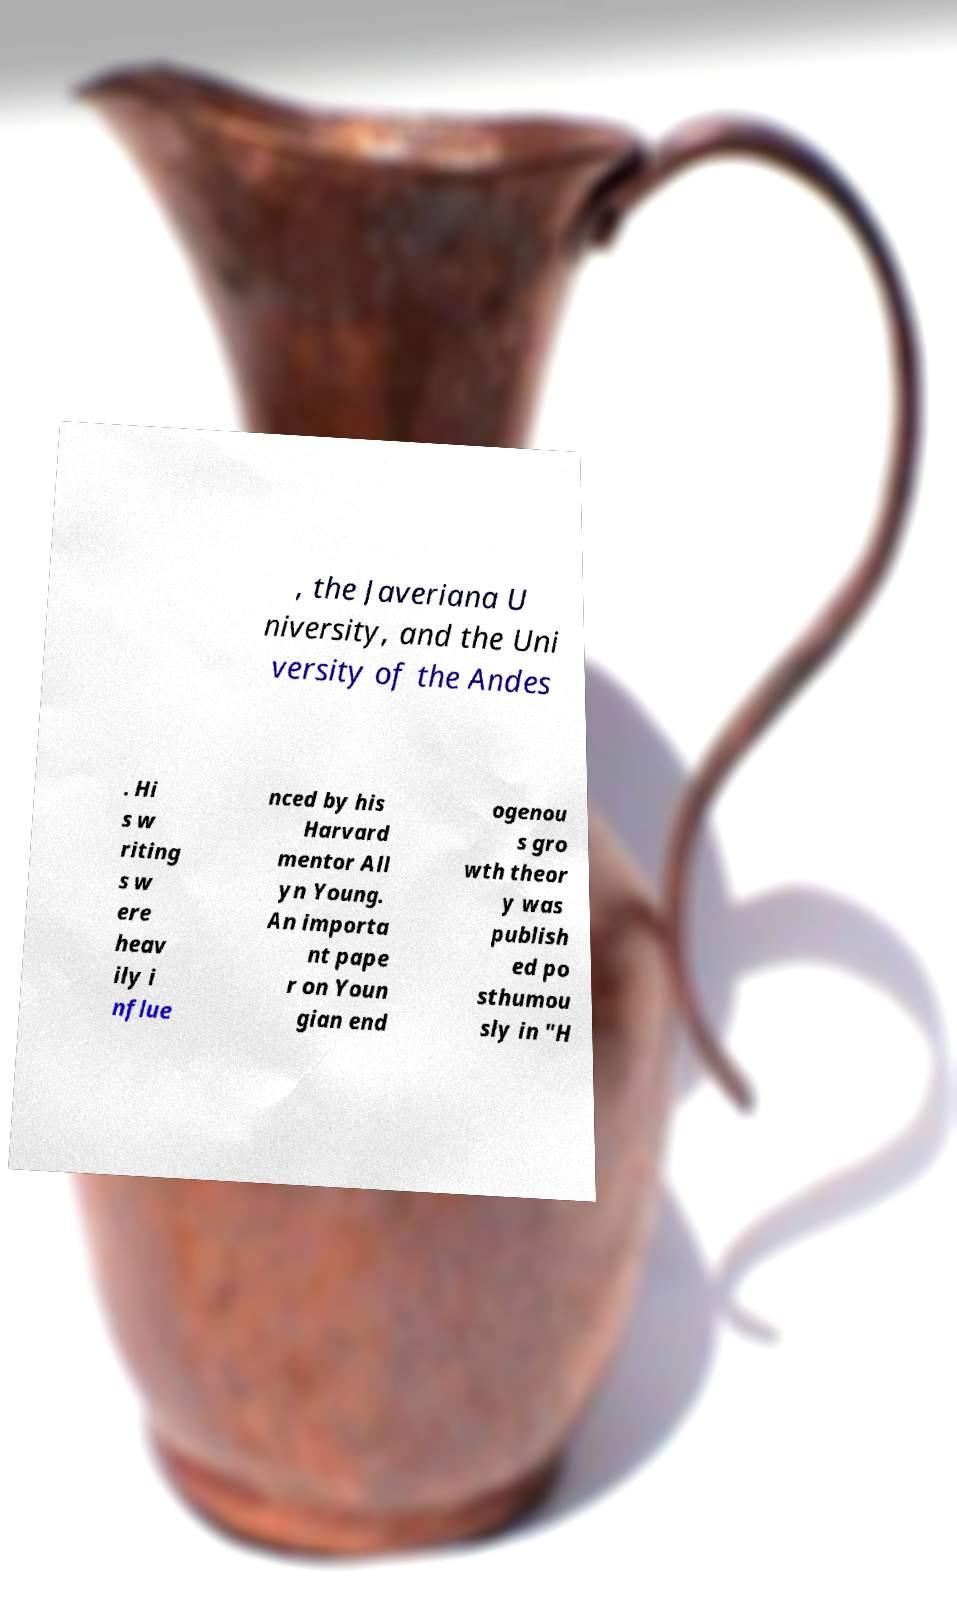Could you assist in decoding the text presented in this image and type it out clearly? , the Javeriana U niversity, and the Uni versity of the Andes . Hi s w riting s w ere heav ily i nflue nced by his Harvard mentor All yn Young. An importa nt pape r on Youn gian end ogenou s gro wth theor y was publish ed po sthumou sly in "H 